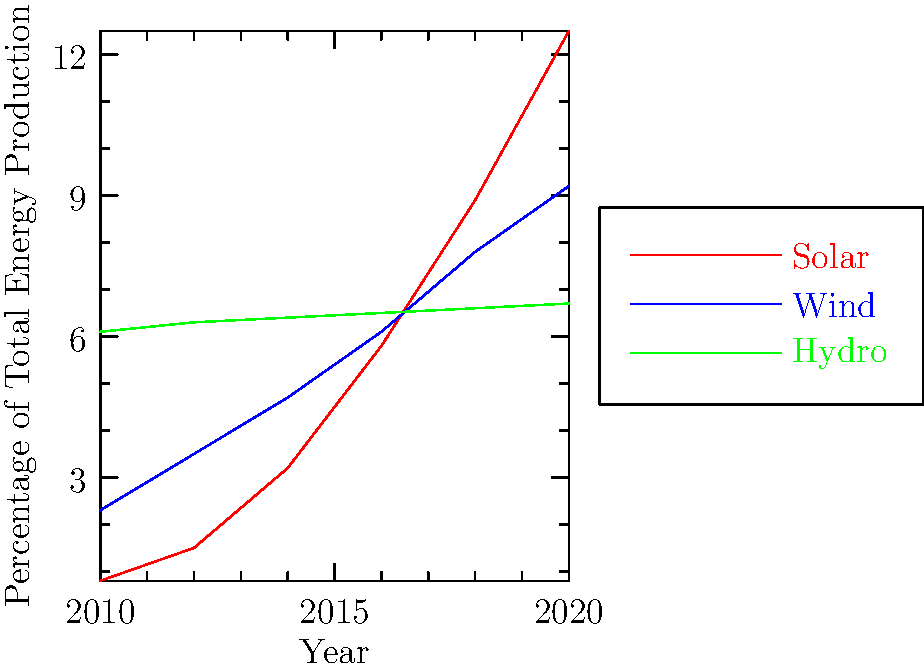As a PR specialist in the energy sector, you're presenting this graph to stakeholders. Which renewable energy source shows the most dramatic growth from 2010 to 2020, and how might this trend impact your communication strategy for different energy companies? To answer this question, let's analyze the graph step-by-step:

1. Identify the three renewable energy sources: solar (red), wind (blue), and hydro (green).

2. Compare the growth rates:
   - Solar: Increases from 0.8% to 12.5% (steepest curve)
   - Wind: Increases from 2.3% to 9.2% (moderate growth)
   - Hydro: Minimal increase from 6.1% to 6.7% (almost flat line)

3. Determine the most dramatic growth: Solar shows the steepest curve and largest percentage increase.

4. Impact on communication strategy:
   a) For solar companies: Emphasize rapid growth and increasing market share.
   b) For wind companies: Highlight steady growth and reliability.
   c) For hydro companies: Focus on stability and consistent contribution.
   d) For traditional energy companies: Stress the need for diversification and investment in solar.

5. Overall strategy: Frame the rapid growth of solar as an opportunity for innovation and investment across the energy sector, while acknowledging the continued importance of a diverse energy mix.
Answer: Solar energy shows the most dramatic growth; communicate solar's rapid expansion as an opportunity for innovation and investment across the energy sector. 